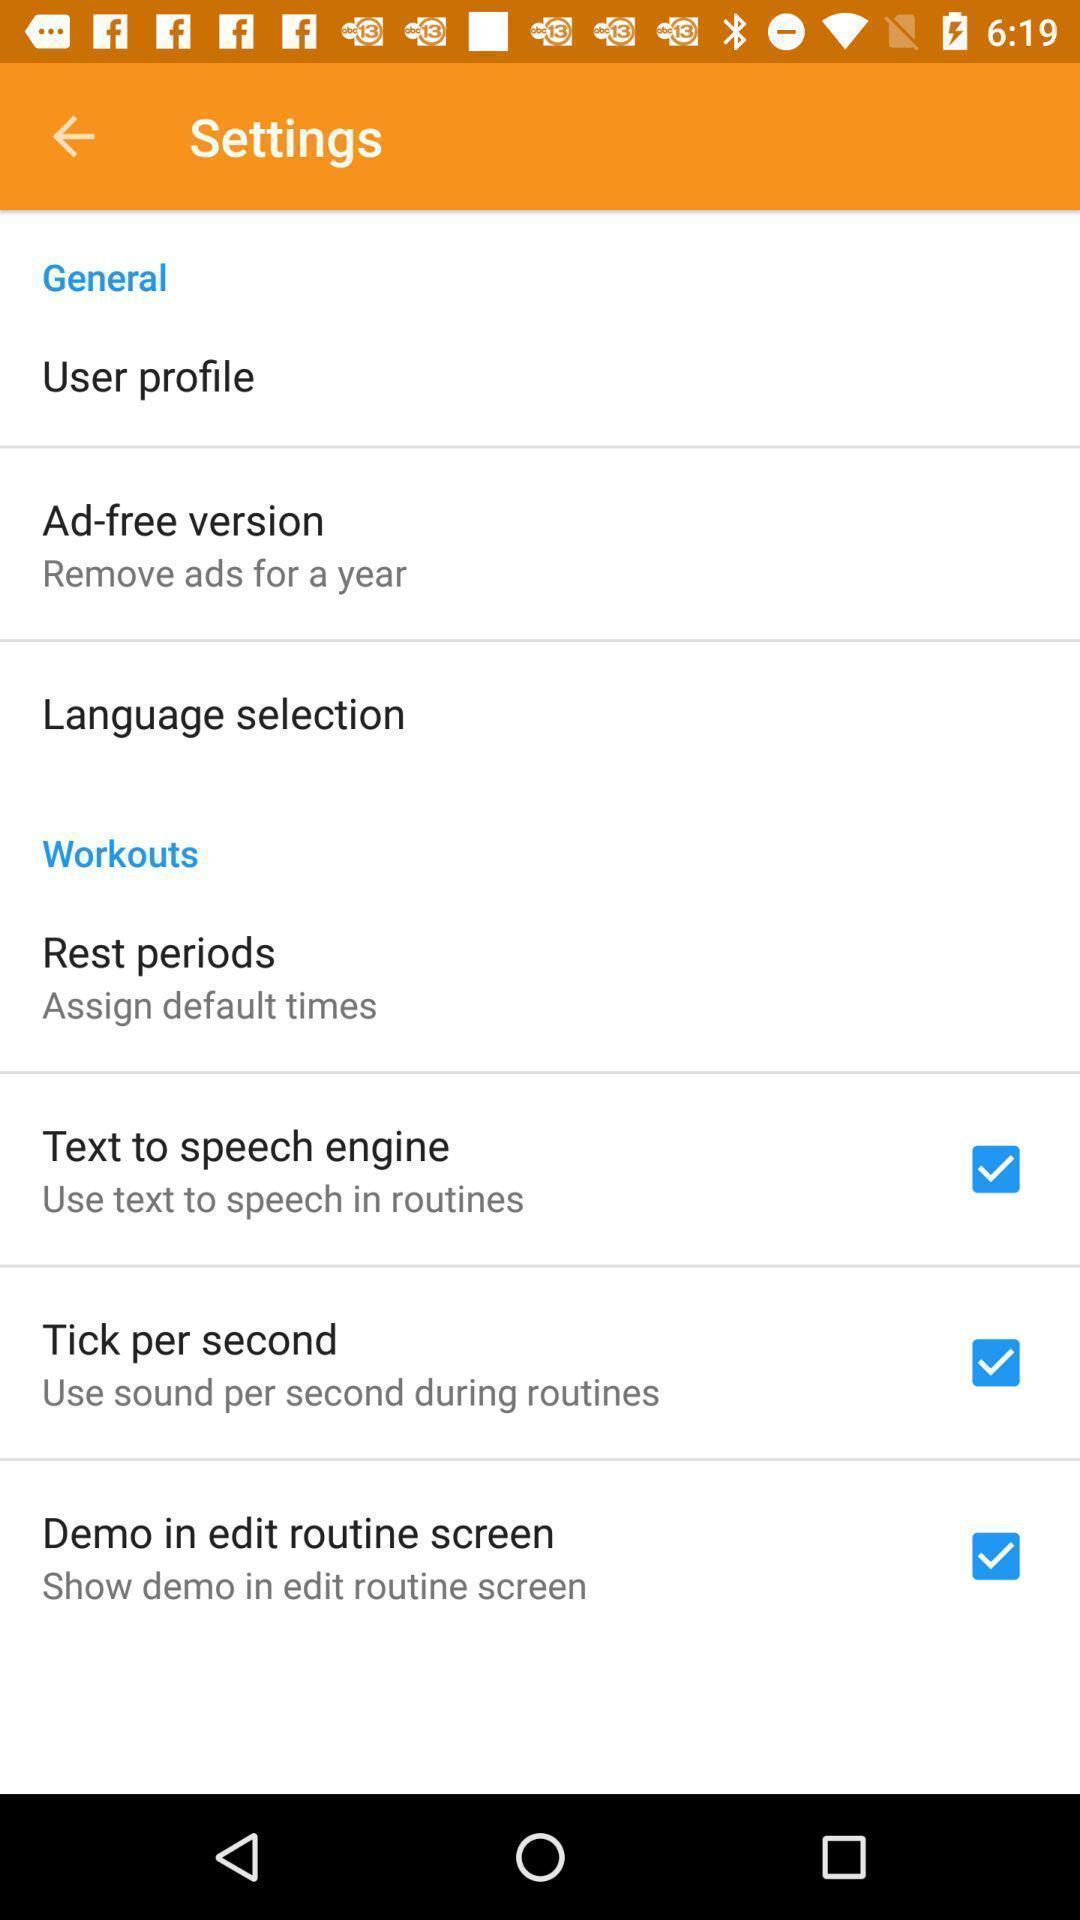Provide a description of this screenshot. Settings page. 